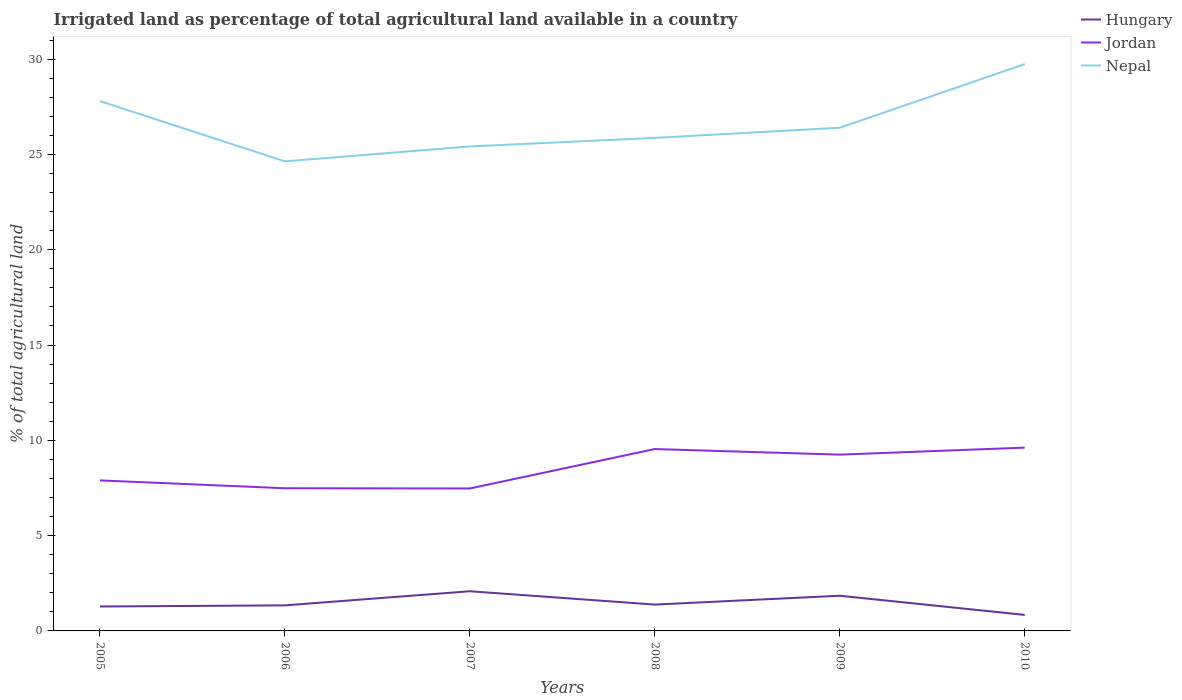How many different coloured lines are there?
Make the answer very short. 3. Does the line corresponding to Jordan intersect with the line corresponding to Hungary?
Offer a very short reply. No. Is the number of lines equal to the number of legend labels?
Offer a very short reply. Yes. Across all years, what is the maximum percentage of irrigated land in Jordan?
Your answer should be compact. 7.47. In which year was the percentage of irrigated land in Hungary maximum?
Offer a very short reply. 2010. What is the total percentage of irrigated land in Jordan in the graph?
Keep it short and to the point. 0.29. What is the difference between the highest and the second highest percentage of irrigated land in Nepal?
Your response must be concise. 5.1. What is the difference between the highest and the lowest percentage of irrigated land in Jordan?
Your response must be concise. 3. Is the percentage of irrigated land in Nepal strictly greater than the percentage of irrigated land in Hungary over the years?
Your answer should be very brief. No. How many lines are there?
Provide a succinct answer. 3. How many years are there in the graph?
Keep it short and to the point. 6. What is the difference between two consecutive major ticks on the Y-axis?
Your answer should be compact. 5. Does the graph contain any zero values?
Your answer should be very brief. No. Does the graph contain grids?
Keep it short and to the point. No. Where does the legend appear in the graph?
Make the answer very short. Top right. How are the legend labels stacked?
Offer a very short reply. Vertical. What is the title of the graph?
Keep it short and to the point. Irrigated land as percentage of total agricultural land available in a country. What is the label or title of the Y-axis?
Your answer should be compact. % of total agricultural land. What is the % of total agricultural land of Hungary in 2005?
Offer a very short reply. 1.28. What is the % of total agricultural land in Jordan in 2005?
Keep it short and to the point. 7.9. What is the % of total agricultural land of Nepal in 2005?
Offer a very short reply. 27.8. What is the % of total agricultural land in Hungary in 2006?
Make the answer very short. 1.34. What is the % of total agricultural land of Jordan in 2006?
Offer a terse response. 7.49. What is the % of total agricultural land of Nepal in 2006?
Give a very brief answer. 24.64. What is the % of total agricultural land of Hungary in 2007?
Your answer should be very brief. 2.08. What is the % of total agricultural land of Jordan in 2007?
Ensure brevity in your answer.  7.47. What is the % of total agricultural land in Nepal in 2007?
Make the answer very short. 25.42. What is the % of total agricultural land of Hungary in 2008?
Keep it short and to the point. 1.38. What is the % of total agricultural land of Jordan in 2008?
Provide a short and direct response. 9.54. What is the % of total agricultural land of Nepal in 2008?
Offer a very short reply. 25.87. What is the % of total agricultural land of Hungary in 2009?
Your answer should be compact. 1.85. What is the % of total agricultural land in Jordan in 2009?
Ensure brevity in your answer.  9.25. What is the % of total agricultural land of Nepal in 2009?
Keep it short and to the point. 26.4. What is the % of total agricultural land of Hungary in 2010?
Keep it short and to the point. 0.84. What is the % of total agricultural land in Jordan in 2010?
Make the answer very short. 9.62. What is the % of total agricultural land of Nepal in 2010?
Your answer should be compact. 29.74. Across all years, what is the maximum % of total agricultural land of Hungary?
Keep it short and to the point. 2.08. Across all years, what is the maximum % of total agricultural land in Jordan?
Give a very brief answer. 9.62. Across all years, what is the maximum % of total agricultural land in Nepal?
Ensure brevity in your answer.  29.74. Across all years, what is the minimum % of total agricultural land in Hungary?
Make the answer very short. 0.84. Across all years, what is the minimum % of total agricultural land in Jordan?
Keep it short and to the point. 7.47. Across all years, what is the minimum % of total agricultural land in Nepal?
Give a very brief answer. 24.64. What is the total % of total agricultural land of Hungary in the graph?
Your response must be concise. 8.77. What is the total % of total agricultural land in Jordan in the graph?
Offer a very short reply. 51.27. What is the total % of total agricultural land of Nepal in the graph?
Give a very brief answer. 159.86. What is the difference between the % of total agricultural land of Hungary in 2005 and that in 2006?
Provide a succinct answer. -0.06. What is the difference between the % of total agricultural land of Jordan in 2005 and that in 2006?
Provide a short and direct response. 0.41. What is the difference between the % of total agricultural land of Nepal in 2005 and that in 2006?
Keep it short and to the point. 3.16. What is the difference between the % of total agricultural land of Hungary in 2005 and that in 2007?
Make the answer very short. -0.8. What is the difference between the % of total agricultural land of Jordan in 2005 and that in 2007?
Your response must be concise. 0.42. What is the difference between the % of total agricultural land in Nepal in 2005 and that in 2007?
Provide a succinct answer. 2.38. What is the difference between the % of total agricultural land of Hungary in 2005 and that in 2008?
Offer a terse response. -0.1. What is the difference between the % of total agricultural land of Jordan in 2005 and that in 2008?
Offer a very short reply. -1.65. What is the difference between the % of total agricultural land in Nepal in 2005 and that in 2008?
Your answer should be very brief. 1.93. What is the difference between the % of total agricultural land in Hungary in 2005 and that in 2009?
Give a very brief answer. -0.57. What is the difference between the % of total agricultural land in Jordan in 2005 and that in 2009?
Offer a terse response. -1.35. What is the difference between the % of total agricultural land of Nepal in 2005 and that in 2009?
Provide a short and direct response. 1.4. What is the difference between the % of total agricultural land in Hungary in 2005 and that in 2010?
Your response must be concise. 0.44. What is the difference between the % of total agricultural land in Jordan in 2005 and that in 2010?
Provide a succinct answer. -1.72. What is the difference between the % of total agricultural land in Nepal in 2005 and that in 2010?
Your response must be concise. -1.94. What is the difference between the % of total agricultural land in Hungary in 2006 and that in 2007?
Make the answer very short. -0.74. What is the difference between the % of total agricultural land of Jordan in 2006 and that in 2007?
Your response must be concise. 0.01. What is the difference between the % of total agricultural land of Nepal in 2006 and that in 2007?
Provide a short and direct response. -0.78. What is the difference between the % of total agricultural land in Hungary in 2006 and that in 2008?
Give a very brief answer. -0.04. What is the difference between the % of total agricultural land in Jordan in 2006 and that in 2008?
Your answer should be compact. -2.06. What is the difference between the % of total agricultural land of Nepal in 2006 and that in 2008?
Offer a very short reply. -1.23. What is the difference between the % of total agricultural land in Hungary in 2006 and that in 2009?
Your response must be concise. -0.5. What is the difference between the % of total agricultural land of Jordan in 2006 and that in 2009?
Offer a very short reply. -1.76. What is the difference between the % of total agricultural land of Nepal in 2006 and that in 2009?
Offer a terse response. -1.77. What is the difference between the % of total agricultural land of Hungary in 2006 and that in 2010?
Offer a very short reply. 0.5. What is the difference between the % of total agricultural land in Jordan in 2006 and that in 2010?
Provide a short and direct response. -2.13. What is the difference between the % of total agricultural land in Nepal in 2006 and that in 2010?
Make the answer very short. -5.1. What is the difference between the % of total agricultural land of Hungary in 2007 and that in 2008?
Give a very brief answer. 0.7. What is the difference between the % of total agricultural land in Jordan in 2007 and that in 2008?
Your answer should be compact. -2.07. What is the difference between the % of total agricultural land in Nepal in 2007 and that in 2008?
Keep it short and to the point. -0.45. What is the difference between the % of total agricultural land in Hungary in 2007 and that in 2009?
Keep it short and to the point. 0.24. What is the difference between the % of total agricultural land in Jordan in 2007 and that in 2009?
Ensure brevity in your answer.  -1.77. What is the difference between the % of total agricultural land of Nepal in 2007 and that in 2009?
Your response must be concise. -0.98. What is the difference between the % of total agricultural land of Hungary in 2007 and that in 2010?
Your answer should be compact. 1.24. What is the difference between the % of total agricultural land of Jordan in 2007 and that in 2010?
Offer a very short reply. -2.14. What is the difference between the % of total agricultural land in Nepal in 2007 and that in 2010?
Provide a short and direct response. -4.32. What is the difference between the % of total agricultural land in Hungary in 2008 and that in 2009?
Provide a succinct answer. -0.46. What is the difference between the % of total agricultural land of Jordan in 2008 and that in 2009?
Make the answer very short. 0.29. What is the difference between the % of total agricultural land in Nepal in 2008 and that in 2009?
Your answer should be compact. -0.53. What is the difference between the % of total agricultural land of Hungary in 2008 and that in 2010?
Give a very brief answer. 0.54. What is the difference between the % of total agricultural land of Jordan in 2008 and that in 2010?
Keep it short and to the point. -0.08. What is the difference between the % of total agricultural land in Nepal in 2008 and that in 2010?
Provide a succinct answer. -3.87. What is the difference between the % of total agricultural land of Hungary in 2009 and that in 2010?
Give a very brief answer. 1.01. What is the difference between the % of total agricultural land of Jordan in 2009 and that in 2010?
Offer a terse response. -0.37. What is the difference between the % of total agricultural land of Nepal in 2009 and that in 2010?
Offer a very short reply. -3.34. What is the difference between the % of total agricultural land of Hungary in 2005 and the % of total agricultural land of Jordan in 2006?
Make the answer very short. -6.2. What is the difference between the % of total agricultural land of Hungary in 2005 and the % of total agricultural land of Nepal in 2006?
Make the answer very short. -23.35. What is the difference between the % of total agricultural land of Jordan in 2005 and the % of total agricultural land of Nepal in 2006?
Ensure brevity in your answer.  -16.74. What is the difference between the % of total agricultural land in Hungary in 2005 and the % of total agricultural land in Jordan in 2007?
Offer a very short reply. -6.19. What is the difference between the % of total agricultural land of Hungary in 2005 and the % of total agricultural land of Nepal in 2007?
Provide a succinct answer. -24.14. What is the difference between the % of total agricultural land in Jordan in 2005 and the % of total agricultural land in Nepal in 2007?
Offer a terse response. -17.52. What is the difference between the % of total agricultural land in Hungary in 2005 and the % of total agricultural land in Jordan in 2008?
Make the answer very short. -8.26. What is the difference between the % of total agricultural land in Hungary in 2005 and the % of total agricultural land in Nepal in 2008?
Your answer should be very brief. -24.59. What is the difference between the % of total agricultural land in Jordan in 2005 and the % of total agricultural land in Nepal in 2008?
Ensure brevity in your answer.  -17.97. What is the difference between the % of total agricultural land in Hungary in 2005 and the % of total agricultural land in Jordan in 2009?
Keep it short and to the point. -7.97. What is the difference between the % of total agricultural land of Hungary in 2005 and the % of total agricultural land of Nepal in 2009?
Offer a terse response. -25.12. What is the difference between the % of total agricultural land in Jordan in 2005 and the % of total agricultural land in Nepal in 2009?
Keep it short and to the point. -18.5. What is the difference between the % of total agricultural land in Hungary in 2005 and the % of total agricultural land in Jordan in 2010?
Your answer should be compact. -8.34. What is the difference between the % of total agricultural land in Hungary in 2005 and the % of total agricultural land in Nepal in 2010?
Your answer should be very brief. -28.46. What is the difference between the % of total agricultural land in Jordan in 2005 and the % of total agricultural land in Nepal in 2010?
Provide a short and direct response. -21.84. What is the difference between the % of total agricultural land in Hungary in 2006 and the % of total agricultural land in Jordan in 2007?
Your answer should be compact. -6.13. What is the difference between the % of total agricultural land in Hungary in 2006 and the % of total agricultural land in Nepal in 2007?
Offer a very short reply. -24.08. What is the difference between the % of total agricultural land of Jordan in 2006 and the % of total agricultural land of Nepal in 2007?
Your answer should be very brief. -17.93. What is the difference between the % of total agricultural land in Hungary in 2006 and the % of total agricultural land in Jordan in 2008?
Provide a short and direct response. -8.2. What is the difference between the % of total agricultural land of Hungary in 2006 and the % of total agricultural land of Nepal in 2008?
Offer a very short reply. -24.53. What is the difference between the % of total agricultural land in Jordan in 2006 and the % of total agricultural land in Nepal in 2008?
Keep it short and to the point. -18.38. What is the difference between the % of total agricultural land of Hungary in 2006 and the % of total agricultural land of Jordan in 2009?
Give a very brief answer. -7.91. What is the difference between the % of total agricultural land in Hungary in 2006 and the % of total agricultural land in Nepal in 2009?
Make the answer very short. -25.06. What is the difference between the % of total agricultural land of Jordan in 2006 and the % of total agricultural land of Nepal in 2009?
Ensure brevity in your answer.  -18.92. What is the difference between the % of total agricultural land in Hungary in 2006 and the % of total agricultural land in Jordan in 2010?
Make the answer very short. -8.28. What is the difference between the % of total agricultural land of Hungary in 2006 and the % of total agricultural land of Nepal in 2010?
Keep it short and to the point. -28.4. What is the difference between the % of total agricultural land in Jordan in 2006 and the % of total agricultural land in Nepal in 2010?
Give a very brief answer. -22.25. What is the difference between the % of total agricultural land of Hungary in 2007 and the % of total agricultural land of Jordan in 2008?
Your answer should be very brief. -7.46. What is the difference between the % of total agricultural land of Hungary in 2007 and the % of total agricultural land of Nepal in 2008?
Give a very brief answer. -23.79. What is the difference between the % of total agricultural land of Jordan in 2007 and the % of total agricultural land of Nepal in 2008?
Make the answer very short. -18.39. What is the difference between the % of total agricultural land of Hungary in 2007 and the % of total agricultural land of Jordan in 2009?
Offer a very short reply. -7.17. What is the difference between the % of total agricultural land in Hungary in 2007 and the % of total agricultural land in Nepal in 2009?
Your answer should be compact. -24.32. What is the difference between the % of total agricultural land of Jordan in 2007 and the % of total agricultural land of Nepal in 2009?
Ensure brevity in your answer.  -18.93. What is the difference between the % of total agricultural land in Hungary in 2007 and the % of total agricultural land in Jordan in 2010?
Your answer should be compact. -7.54. What is the difference between the % of total agricultural land in Hungary in 2007 and the % of total agricultural land in Nepal in 2010?
Keep it short and to the point. -27.66. What is the difference between the % of total agricultural land of Jordan in 2007 and the % of total agricultural land of Nepal in 2010?
Give a very brief answer. -22.26. What is the difference between the % of total agricultural land of Hungary in 2008 and the % of total agricultural land of Jordan in 2009?
Give a very brief answer. -7.87. What is the difference between the % of total agricultural land in Hungary in 2008 and the % of total agricultural land in Nepal in 2009?
Ensure brevity in your answer.  -25.02. What is the difference between the % of total agricultural land of Jordan in 2008 and the % of total agricultural land of Nepal in 2009?
Offer a terse response. -16.86. What is the difference between the % of total agricultural land of Hungary in 2008 and the % of total agricultural land of Jordan in 2010?
Keep it short and to the point. -8.24. What is the difference between the % of total agricultural land of Hungary in 2008 and the % of total agricultural land of Nepal in 2010?
Provide a succinct answer. -28.36. What is the difference between the % of total agricultural land in Jordan in 2008 and the % of total agricultural land in Nepal in 2010?
Make the answer very short. -20.2. What is the difference between the % of total agricultural land of Hungary in 2009 and the % of total agricultural land of Jordan in 2010?
Your answer should be compact. -7.77. What is the difference between the % of total agricultural land of Hungary in 2009 and the % of total agricultural land of Nepal in 2010?
Your answer should be compact. -27.89. What is the difference between the % of total agricultural land of Jordan in 2009 and the % of total agricultural land of Nepal in 2010?
Give a very brief answer. -20.49. What is the average % of total agricultural land in Hungary per year?
Ensure brevity in your answer.  1.46. What is the average % of total agricultural land of Jordan per year?
Keep it short and to the point. 8.54. What is the average % of total agricultural land in Nepal per year?
Your answer should be compact. 26.64. In the year 2005, what is the difference between the % of total agricultural land of Hungary and % of total agricultural land of Jordan?
Keep it short and to the point. -6.62. In the year 2005, what is the difference between the % of total agricultural land in Hungary and % of total agricultural land in Nepal?
Your answer should be compact. -26.52. In the year 2005, what is the difference between the % of total agricultural land of Jordan and % of total agricultural land of Nepal?
Ensure brevity in your answer.  -19.9. In the year 2006, what is the difference between the % of total agricultural land of Hungary and % of total agricultural land of Jordan?
Your answer should be compact. -6.14. In the year 2006, what is the difference between the % of total agricultural land of Hungary and % of total agricultural land of Nepal?
Give a very brief answer. -23.29. In the year 2006, what is the difference between the % of total agricultural land of Jordan and % of total agricultural land of Nepal?
Provide a succinct answer. -17.15. In the year 2007, what is the difference between the % of total agricultural land of Hungary and % of total agricultural land of Jordan?
Your answer should be very brief. -5.39. In the year 2007, what is the difference between the % of total agricultural land in Hungary and % of total agricultural land in Nepal?
Your answer should be compact. -23.34. In the year 2007, what is the difference between the % of total agricultural land of Jordan and % of total agricultural land of Nepal?
Your answer should be very brief. -17.95. In the year 2008, what is the difference between the % of total agricultural land of Hungary and % of total agricultural land of Jordan?
Keep it short and to the point. -8.16. In the year 2008, what is the difference between the % of total agricultural land in Hungary and % of total agricultural land in Nepal?
Your response must be concise. -24.48. In the year 2008, what is the difference between the % of total agricultural land of Jordan and % of total agricultural land of Nepal?
Offer a terse response. -16.32. In the year 2009, what is the difference between the % of total agricultural land of Hungary and % of total agricultural land of Jordan?
Ensure brevity in your answer.  -7.4. In the year 2009, what is the difference between the % of total agricultural land of Hungary and % of total agricultural land of Nepal?
Provide a succinct answer. -24.55. In the year 2009, what is the difference between the % of total agricultural land in Jordan and % of total agricultural land in Nepal?
Offer a terse response. -17.15. In the year 2010, what is the difference between the % of total agricultural land of Hungary and % of total agricultural land of Jordan?
Your answer should be compact. -8.78. In the year 2010, what is the difference between the % of total agricultural land of Hungary and % of total agricultural land of Nepal?
Provide a short and direct response. -28.9. In the year 2010, what is the difference between the % of total agricultural land in Jordan and % of total agricultural land in Nepal?
Give a very brief answer. -20.12. What is the ratio of the % of total agricultural land of Hungary in 2005 to that in 2006?
Ensure brevity in your answer.  0.95. What is the ratio of the % of total agricultural land of Jordan in 2005 to that in 2006?
Keep it short and to the point. 1.06. What is the ratio of the % of total agricultural land of Nepal in 2005 to that in 2006?
Keep it short and to the point. 1.13. What is the ratio of the % of total agricultural land in Hungary in 2005 to that in 2007?
Your response must be concise. 0.62. What is the ratio of the % of total agricultural land in Jordan in 2005 to that in 2007?
Offer a terse response. 1.06. What is the ratio of the % of total agricultural land in Nepal in 2005 to that in 2007?
Your answer should be compact. 1.09. What is the ratio of the % of total agricultural land in Hungary in 2005 to that in 2008?
Provide a short and direct response. 0.93. What is the ratio of the % of total agricultural land in Jordan in 2005 to that in 2008?
Ensure brevity in your answer.  0.83. What is the ratio of the % of total agricultural land of Nepal in 2005 to that in 2008?
Your answer should be very brief. 1.07. What is the ratio of the % of total agricultural land of Hungary in 2005 to that in 2009?
Provide a short and direct response. 0.69. What is the ratio of the % of total agricultural land in Jordan in 2005 to that in 2009?
Provide a succinct answer. 0.85. What is the ratio of the % of total agricultural land in Nepal in 2005 to that in 2009?
Your answer should be very brief. 1.05. What is the ratio of the % of total agricultural land in Hungary in 2005 to that in 2010?
Your answer should be compact. 1.52. What is the ratio of the % of total agricultural land of Jordan in 2005 to that in 2010?
Your response must be concise. 0.82. What is the ratio of the % of total agricultural land of Nepal in 2005 to that in 2010?
Your answer should be compact. 0.93. What is the ratio of the % of total agricultural land of Hungary in 2006 to that in 2007?
Offer a very short reply. 0.64. What is the ratio of the % of total agricultural land in Nepal in 2006 to that in 2007?
Your response must be concise. 0.97. What is the ratio of the % of total agricultural land in Hungary in 2006 to that in 2008?
Your response must be concise. 0.97. What is the ratio of the % of total agricultural land of Jordan in 2006 to that in 2008?
Keep it short and to the point. 0.78. What is the ratio of the % of total agricultural land of Hungary in 2006 to that in 2009?
Give a very brief answer. 0.73. What is the ratio of the % of total agricultural land of Jordan in 2006 to that in 2009?
Offer a terse response. 0.81. What is the ratio of the % of total agricultural land of Nepal in 2006 to that in 2009?
Your response must be concise. 0.93. What is the ratio of the % of total agricultural land in Hungary in 2006 to that in 2010?
Provide a short and direct response. 1.6. What is the ratio of the % of total agricultural land of Jordan in 2006 to that in 2010?
Make the answer very short. 0.78. What is the ratio of the % of total agricultural land in Nepal in 2006 to that in 2010?
Keep it short and to the point. 0.83. What is the ratio of the % of total agricultural land in Hungary in 2007 to that in 2008?
Make the answer very short. 1.51. What is the ratio of the % of total agricultural land of Jordan in 2007 to that in 2008?
Give a very brief answer. 0.78. What is the ratio of the % of total agricultural land of Nepal in 2007 to that in 2008?
Provide a succinct answer. 0.98. What is the ratio of the % of total agricultural land of Hungary in 2007 to that in 2009?
Make the answer very short. 1.13. What is the ratio of the % of total agricultural land in Jordan in 2007 to that in 2009?
Offer a very short reply. 0.81. What is the ratio of the % of total agricultural land of Nepal in 2007 to that in 2009?
Ensure brevity in your answer.  0.96. What is the ratio of the % of total agricultural land of Hungary in 2007 to that in 2010?
Keep it short and to the point. 2.48. What is the ratio of the % of total agricultural land in Jordan in 2007 to that in 2010?
Provide a succinct answer. 0.78. What is the ratio of the % of total agricultural land of Nepal in 2007 to that in 2010?
Ensure brevity in your answer.  0.85. What is the ratio of the % of total agricultural land of Hungary in 2008 to that in 2009?
Give a very brief answer. 0.75. What is the ratio of the % of total agricultural land in Jordan in 2008 to that in 2009?
Offer a very short reply. 1.03. What is the ratio of the % of total agricultural land in Nepal in 2008 to that in 2009?
Provide a short and direct response. 0.98. What is the ratio of the % of total agricultural land in Hungary in 2008 to that in 2010?
Provide a succinct answer. 1.65. What is the ratio of the % of total agricultural land in Nepal in 2008 to that in 2010?
Your answer should be compact. 0.87. What is the ratio of the % of total agricultural land in Hungary in 2009 to that in 2010?
Ensure brevity in your answer.  2.2. What is the ratio of the % of total agricultural land of Jordan in 2009 to that in 2010?
Provide a short and direct response. 0.96. What is the ratio of the % of total agricultural land in Nepal in 2009 to that in 2010?
Give a very brief answer. 0.89. What is the difference between the highest and the second highest % of total agricultural land of Hungary?
Offer a very short reply. 0.24. What is the difference between the highest and the second highest % of total agricultural land of Jordan?
Your answer should be very brief. 0.08. What is the difference between the highest and the second highest % of total agricultural land in Nepal?
Your answer should be compact. 1.94. What is the difference between the highest and the lowest % of total agricultural land in Hungary?
Give a very brief answer. 1.24. What is the difference between the highest and the lowest % of total agricultural land in Jordan?
Your response must be concise. 2.14. What is the difference between the highest and the lowest % of total agricultural land of Nepal?
Your answer should be very brief. 5.1. 